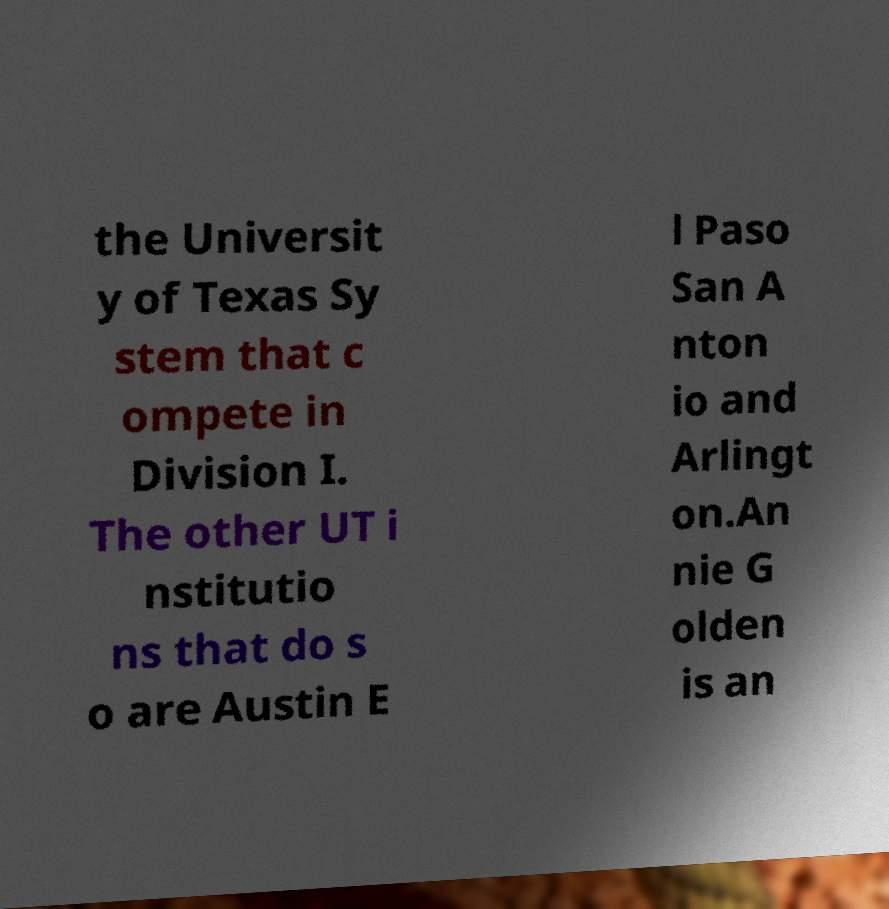Can you accurately transcribe the text from the provided image for me? the Universit y of Texas Sy stem that c ompete in Division I. The other UT i nstitutio ns that do s o are Austin E l Paso San A nton io and Arlingt on.An nie G olden is an 